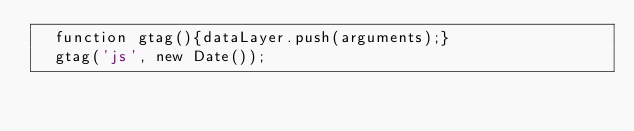<code> <loc_0><loc_0><loc_500><loc_500><_HTML_>  function gtag(){dataLayer.push(arguments);}
  gtag('js', new Date());
</code> 